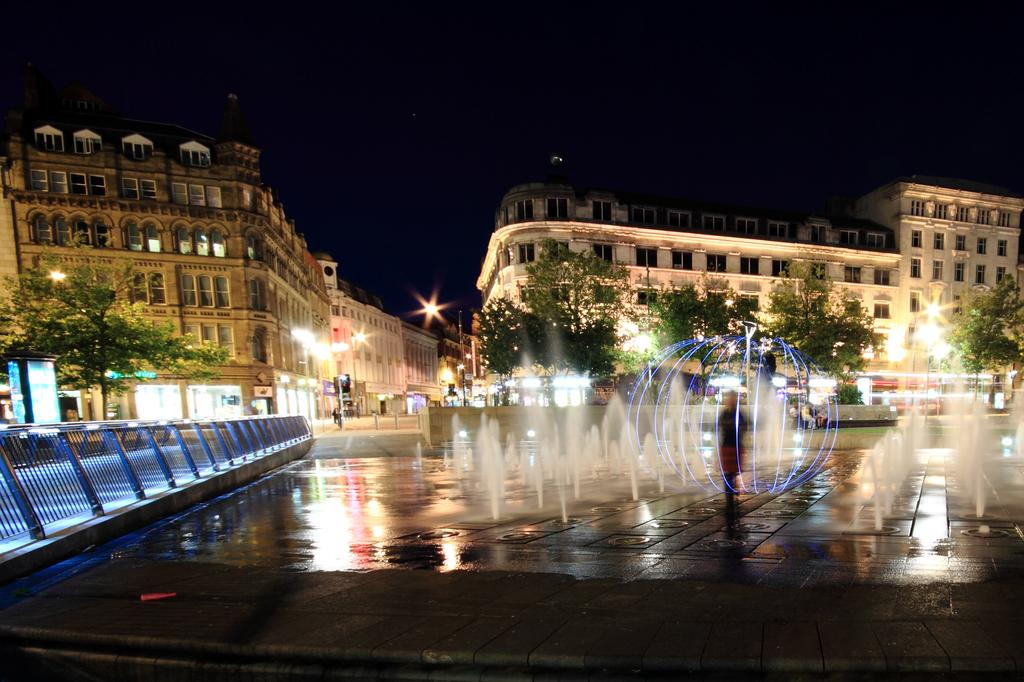What can be seen in the image that provides water? There are fountains in the image that provide water. Is there anyone present in the image? Yes, there is a person standing in the image. What can be seen on the left side of the image? There is railing on the left side of the image. What type of natural elements are visible in the background of the image? There are many trees in the background of the image. What type of artificial elements are visible in the background of the image? There are lights and buildings in the background of the image. What part of the natural environment is visible in the background of the image? The sky is visible in the background of the image. Where is the cactus located in the image? There is no cactus present in the image. What type of throne is the person sitting on in the image? There is no throne present in the image; the person is standing. 